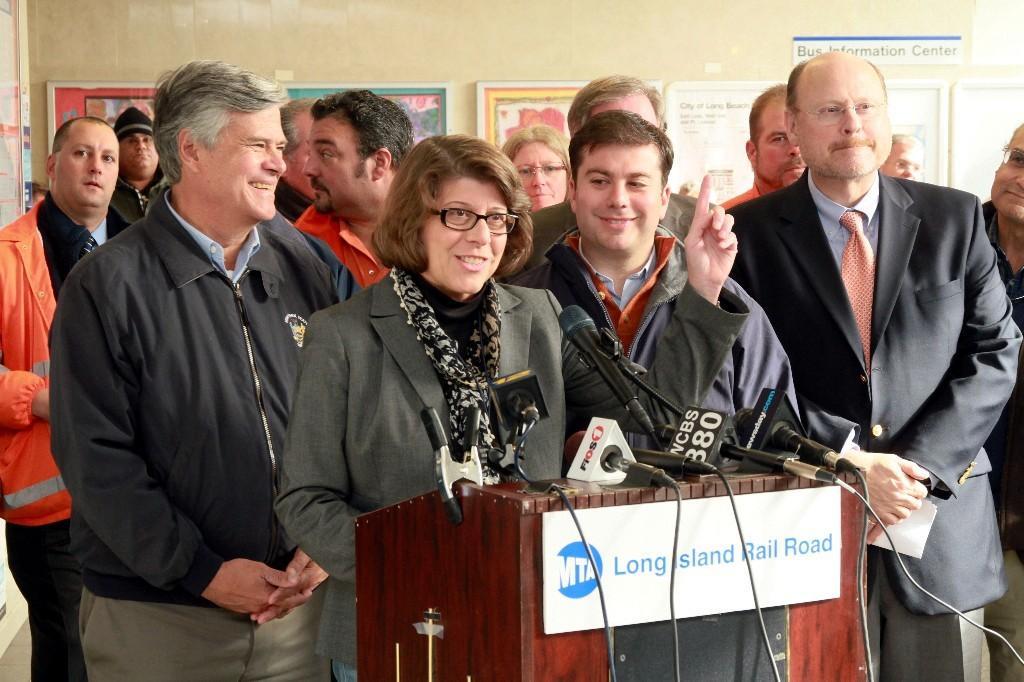Could you give a brief overview of what you see in this image? In this image we can see persons standing on the floor, mics attached to the cables placed on the podium and wall hangings attached to the wall. 